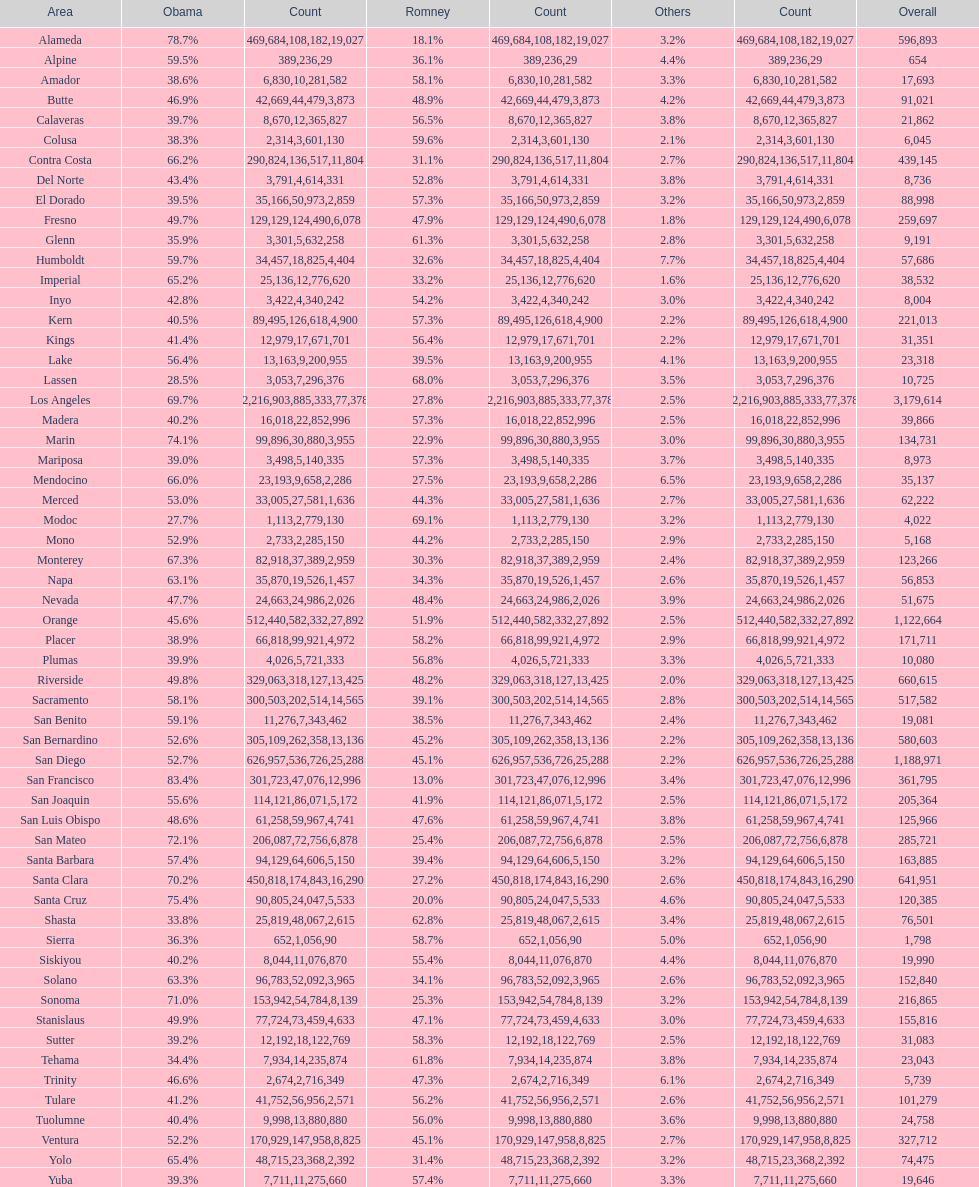How many counties had at least 75% of the votes for obama? 3. 